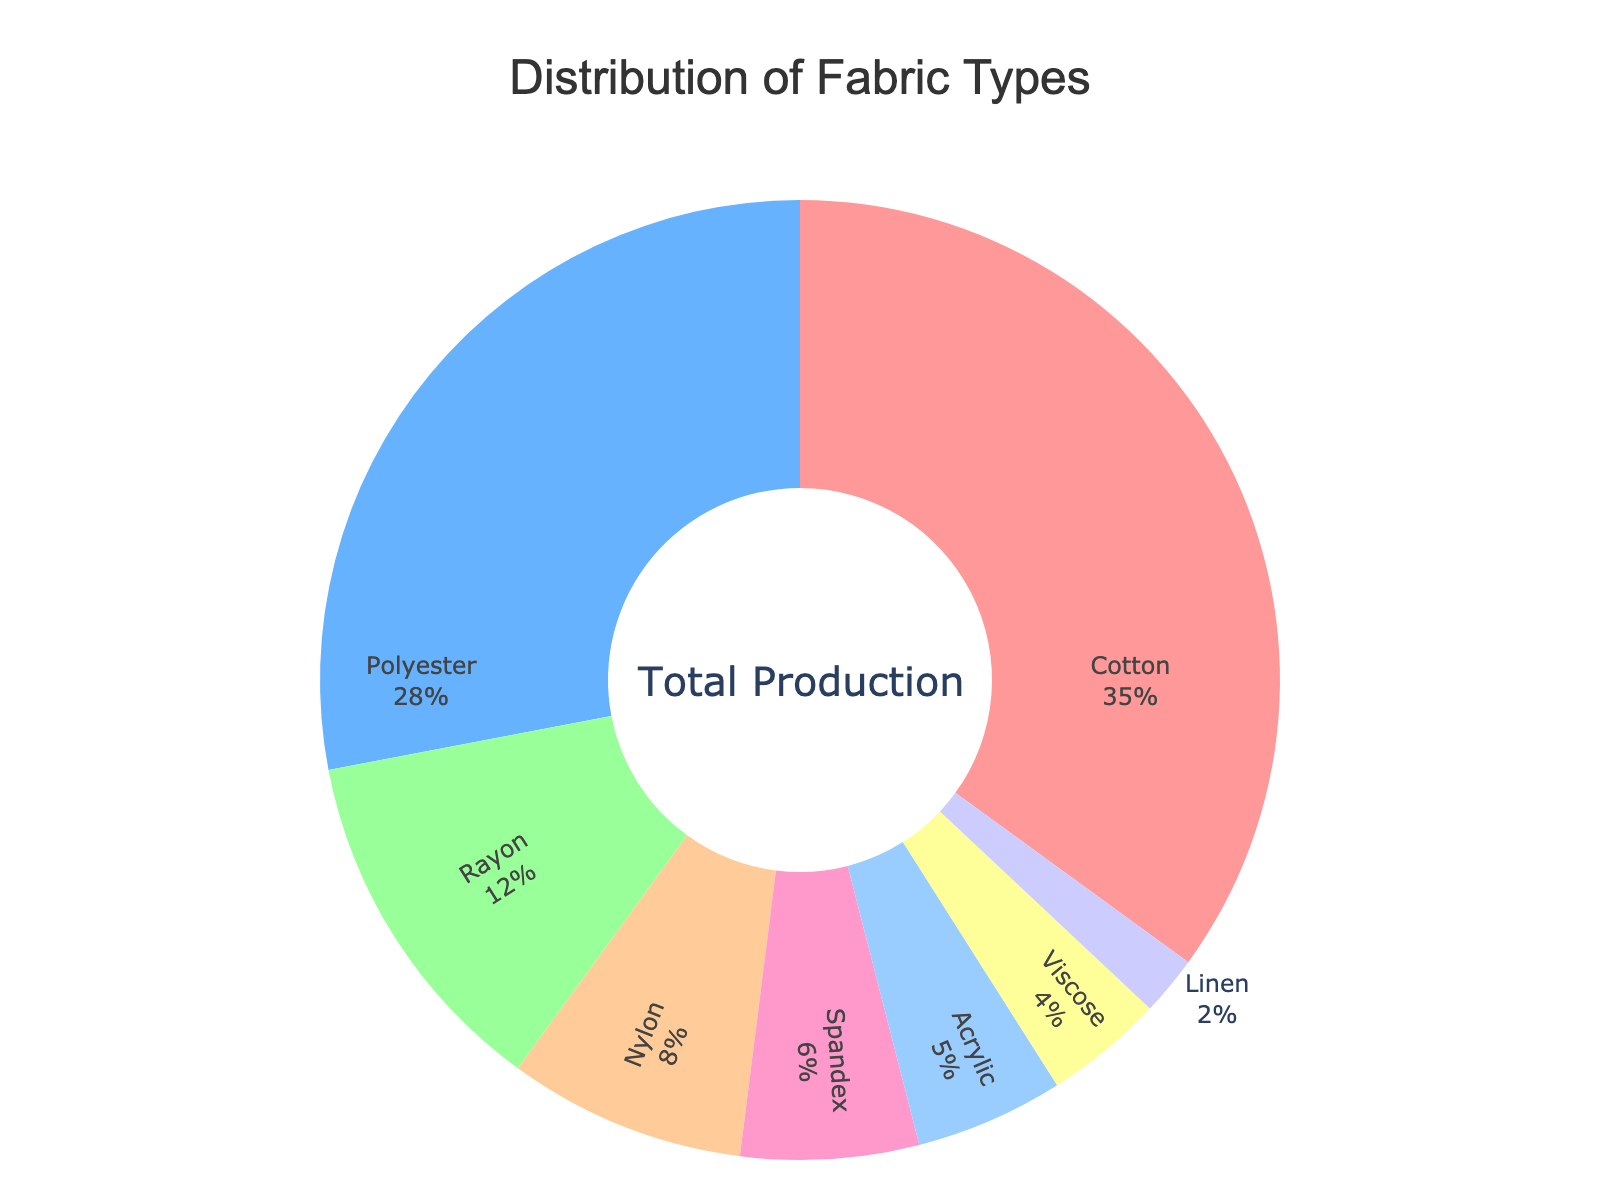Which fabric type has the highest production percentage? Look at the pie chart and identify the fabric type occupying the largest portion of the chart. The label shows Cotton has 35%.
Answer: Cotton Which fabric type has the smallest production percentage? Look at the pie chart and identify the fabric type occupying the smallest section. The label shows Linen has 2%.
Answer: Linen What is the combined production percentage of Cotton and Polyester? From the chart, Cotton is 35% and Polyester is 28%. Add them together: 35% + 28% = 63%.
Answer: 63% Is the production percentage of Nylon greater than that of Acrylic? Compare the percentages shown in the chart. Nylon is at 8%, and Acrylic is at 5%. Yes, 8% is greater than 5%.
Answer: Yes How much more production percentage does Cotton have compared to Rayon? Calculate the difference in the percentages of Cotton and Rayon from the chart: 35% - 12% = 23%.
Answer: 23% What is the total production percentage of synthetic fabrics (Polyester, Nylon, Spandex, Acrylic)? Sum the percentages from the chart: Polyester (28%) + Nylon (8%) + Spandex (6%) + Acrylic (5%) = 47%.
Answer: 47% Does Rayon contribute more to the production percentage than Spandex? Compare Rayon's production percentage (12%) to Spandex's (6%) from the chart. Yes, 12% is greater than 6%.
Answer: Yes Which fabric type is represented by the light blue section of the chart? Identify the section of the chart colored light blue. The label shows that Polyester is colored light blue.
Answer: Polyester What is the median production percentage of all fabric types shown in the chart? List out the production percentages: 35, 28, 12, 8, 6, 5, 4, and 2, then find the median (middle value). Since there is an even number of values, average the two middle values: (8 + 6) / 2 = 7.
Answer: 7 What proportion of the distribution is made up by Spandex, Acrylic, and Viscose combined? Add the percentages of Spandex (6%), Acrylic (5%), and Viscose (4%): 6% + 5% + 4% = 15%.
Answer: 15% 